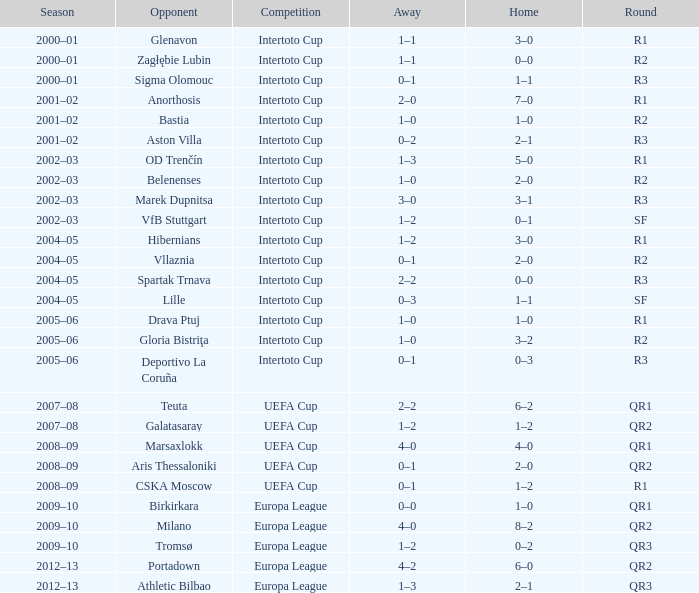What is the home score with marek dupnitsa as opponent? 3–1. 